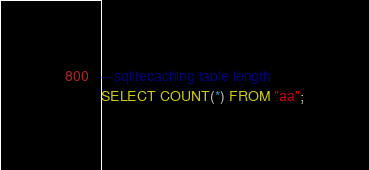Convert code to text. <code><loc_0><loc_0><loc_500><loc_500><_SQL_>-- sqlitecaching table length
SELECT COUNT(*) FROM "aa";
</code> 